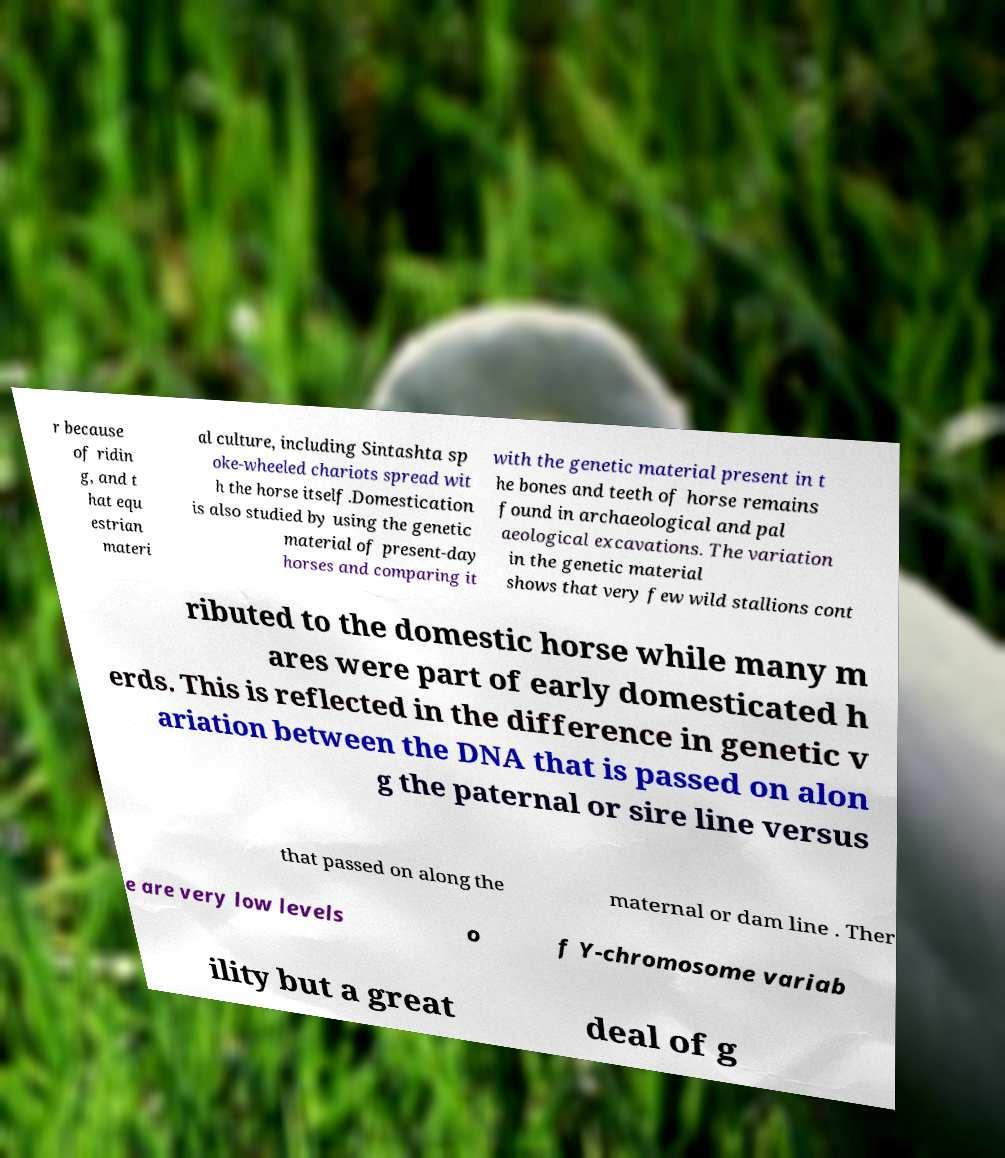Could you assist in decoding the text presented in this image and type it out clearly? r because of ridin g, and t hat equ estrian materi al culture, including Sintashta sp oke-wheeled chariots spread wit h the horse itself.Domestication is also studied by using the genetic material of present-day horses and comparing it with the genetic material present in t he bones and teeth of horse remains found in archaeological and pal aeological excavations. The variation in the genetic material shows that very few wild stallions cont ributed to the domestic horse while many m ares were part of early domesticated h erds. This is reflected in the difference in genetic v ariation between the DNA that is passed on alon g the paternal or sire line versus that passed on along the maternal or dam line . Ther e are very low levels o f Y-chromosome variab ility but a great deal of g 